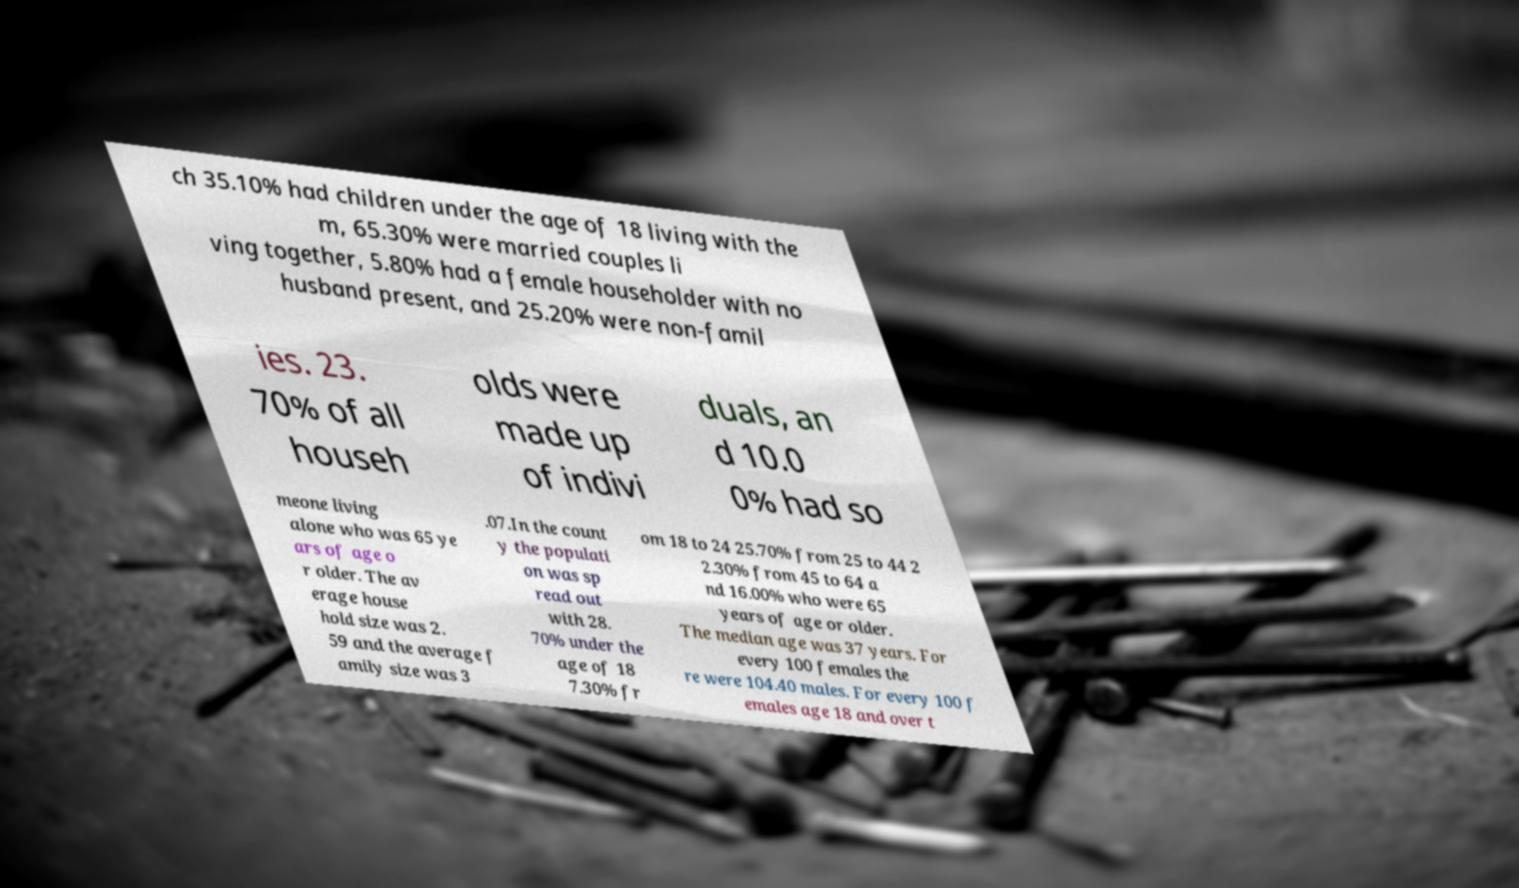For documentation purposes, I need the text within this image transcribed. Could you provide that? ch 35.10% had children under the age of 18 living with the m, 65.30% were married couples li ving together, 5.80% had a female householder with no husband present, and 25.20% were non-famil ies. 23. 70% of all househ olds were made up of indivi duals, an d 10.0 0% had so meone living alone who was 65 ye ars of age o r older. The av erage house hold size was 2. 59 and the average f amily size was 3 .07.In the count y the populati on was sp read out with 28. 70% under the age of 18 7.30% fr om 18 to 24 25.70% from 25 to 44 2 2.30% from 45 to 64 a nd 16.00% who were 65 years of age or older. The median age was 37 years. For every 100 females the re were 104.40 males. For every 100 f emales age 18 and over t 